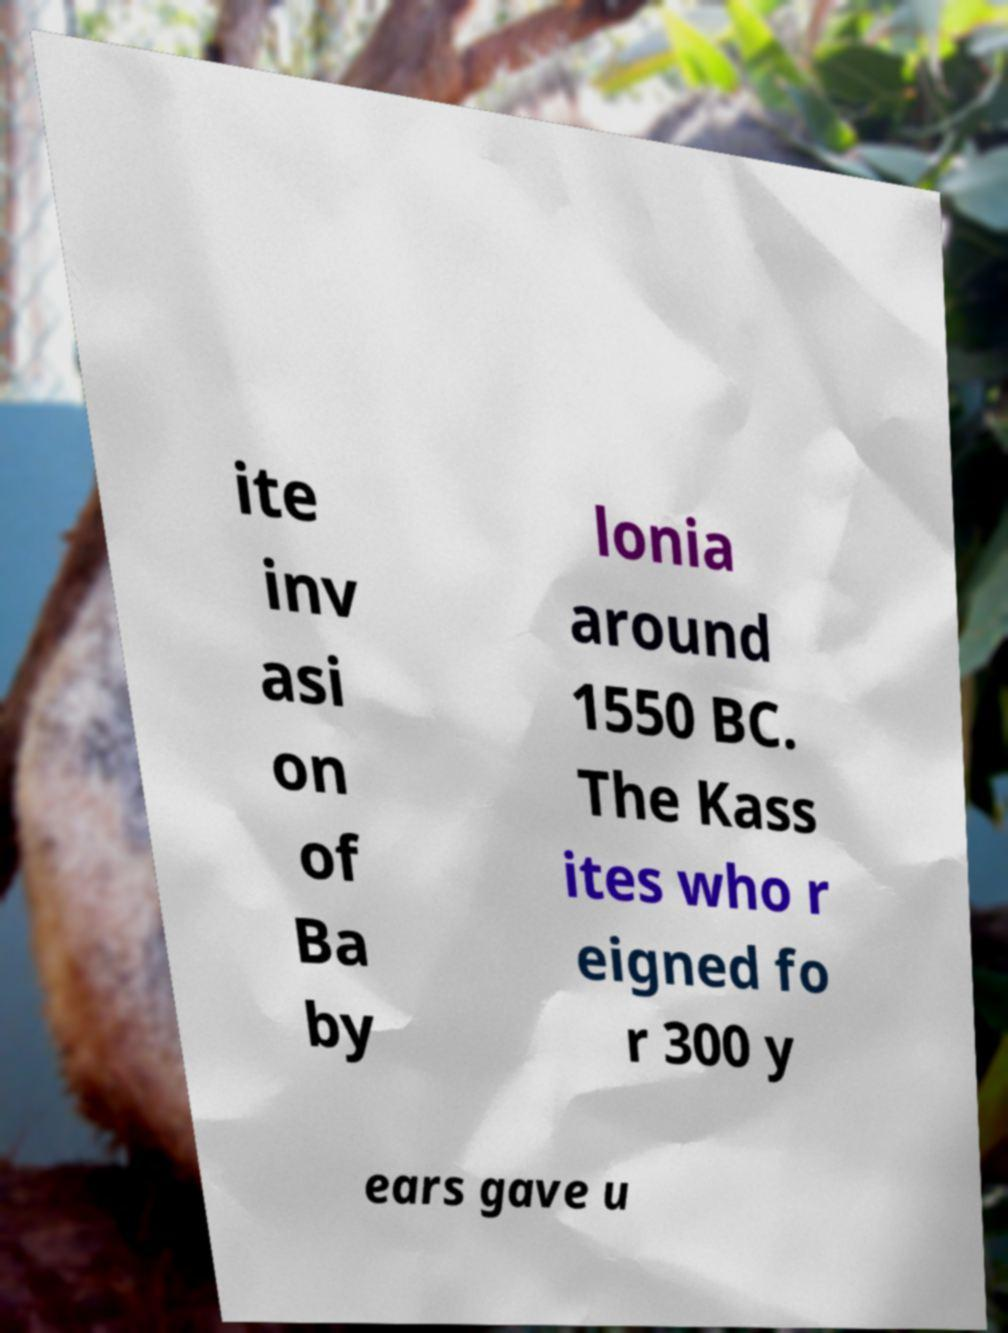Could you assist in decoding the text presented in this image and type it out clearly? ite inv asi on of Ba by lonia around 1550 BC. The Kass ites who r eigned fo r 300 y ears gave u 